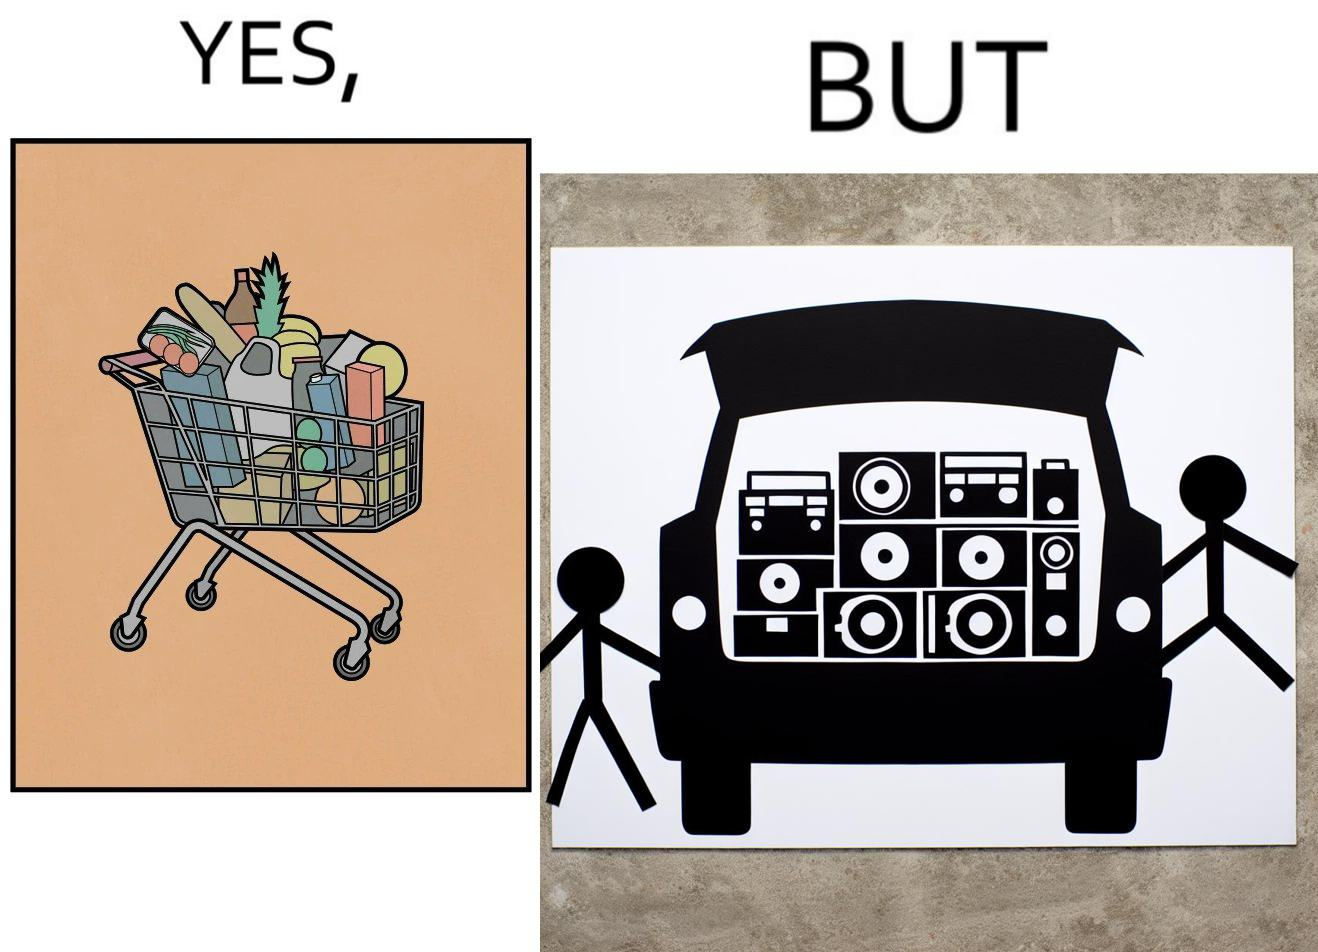Provide a description of this image. The image is ironic, because a car trunk was earlier designed to keep some extra luggage or things but people nowadays get speakers installed in the trunk which in turn reduces the space in the trunk and making it difficult for people to store the extra luggage in the trunk 